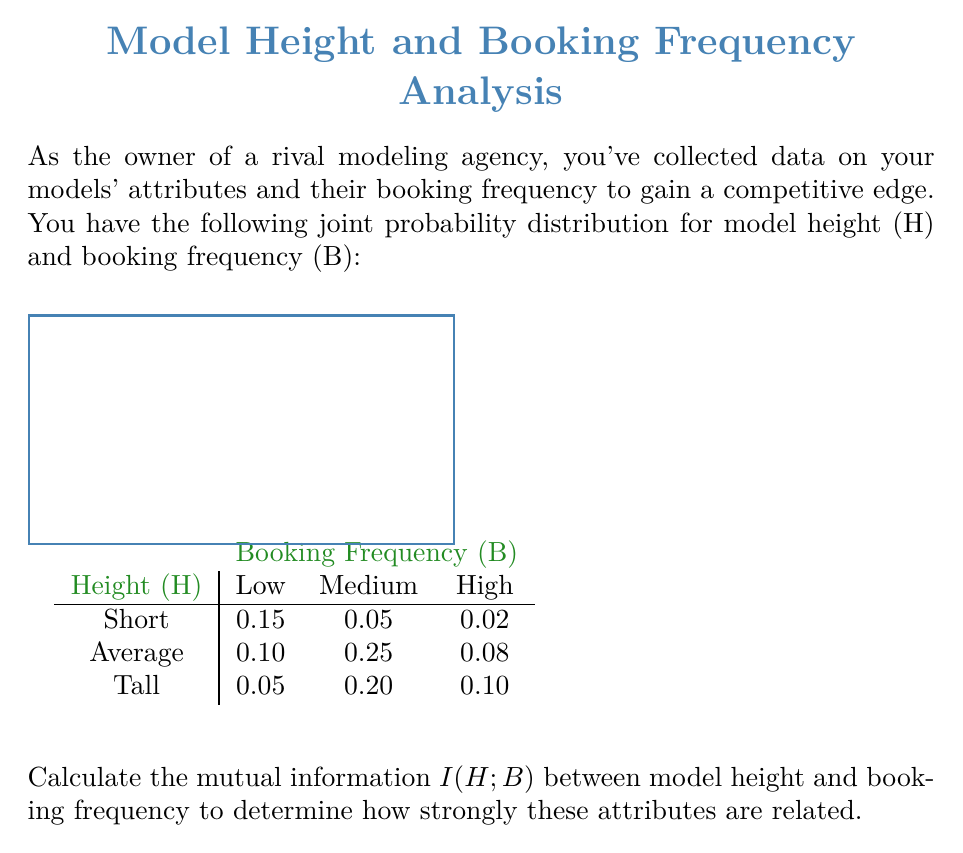Solve this math problem. To calculate the mutual information $I(H;B)$, we'll follow these steps:

1) First, calculate the marginal probabilities:
   $P(H = \text{Short}) = 0.15 + 0.05 + 0.02 = 0.22$
   $P(H = \text{Average}) = 0.10 + 0.25 + 0.08 = 0.43$
   $P(H = \text{Tall}) = 0.05 + 0.20 + 0.10 = 0.35$
   
   $P(B = \text{Low}) = 0.15 + 0.10 + 0.05 = 0.30$
   $P(B = \text{Medium}) = 0.05 + 0.25 + 0.20 = 0.50$
   $P(B = \text{High}) = 0.02 + 0.08 + 0.10 = 0.20$

2) The mutual information is given by:
   $$I(H;B) = \sum_{h \in H} \sum_{b \in B} P(h,b) \log_2 \frac{P(h,b)}{P(h)P(b)}$$

3) Calculate each term:
   $0.15 \log_2 \frac{0.15}{0.22 \times 0.30} = 0.15 \log_2 2.27 = 0.1872$
   $0.05 \log_2 \frac{0.05}{0.22 \times 0.50} = 0.05 \log_2 0.45 = -0.0570$
   $0.02 \log_2 \frac{0.02}{0.22 \times 0.20} = 0.02 \log_2 0.45 = -0.0228$
   $0.10 \log_2 \frac{0.10}{0.43 \times 0.30} = 0.10 \log_2 0.78 = -0.0326$
   $0.25 \log_2 \frac{0.25}{0.43 \times 0.50} = 0.25 \log_2 1.16 = 0.0387$
   $0.08 \log_2 \frac{0.08}{0.43 \times 0.20} = 0.08 \log_2 0.93 = -0.0082$
   $0.05 \log_2 \frac{0.05}{0.35 \times 0.30} = 0.05 \log_2 0.48 = -0.0523$
   $0.20 \log_2 \frac{0.20}{0.35 \times 0.50} = 0.20 \log_2 1.14 = 0.0267$
   $0.10 \log_2 \frac{0.10}{0.35 \times 0.20} = 0.10 \log_2 1.43 = 0.0513$

4) Sum all terms:
   $I(H;B) = 0.1872 - 0.0570 - 0.0228 - 0.0326 + 0.0387 - 0.0082 - 0.0523 + 0.0267 + 0.0513 = 0.1310$ bits
Answer: $0.1310$ bits 